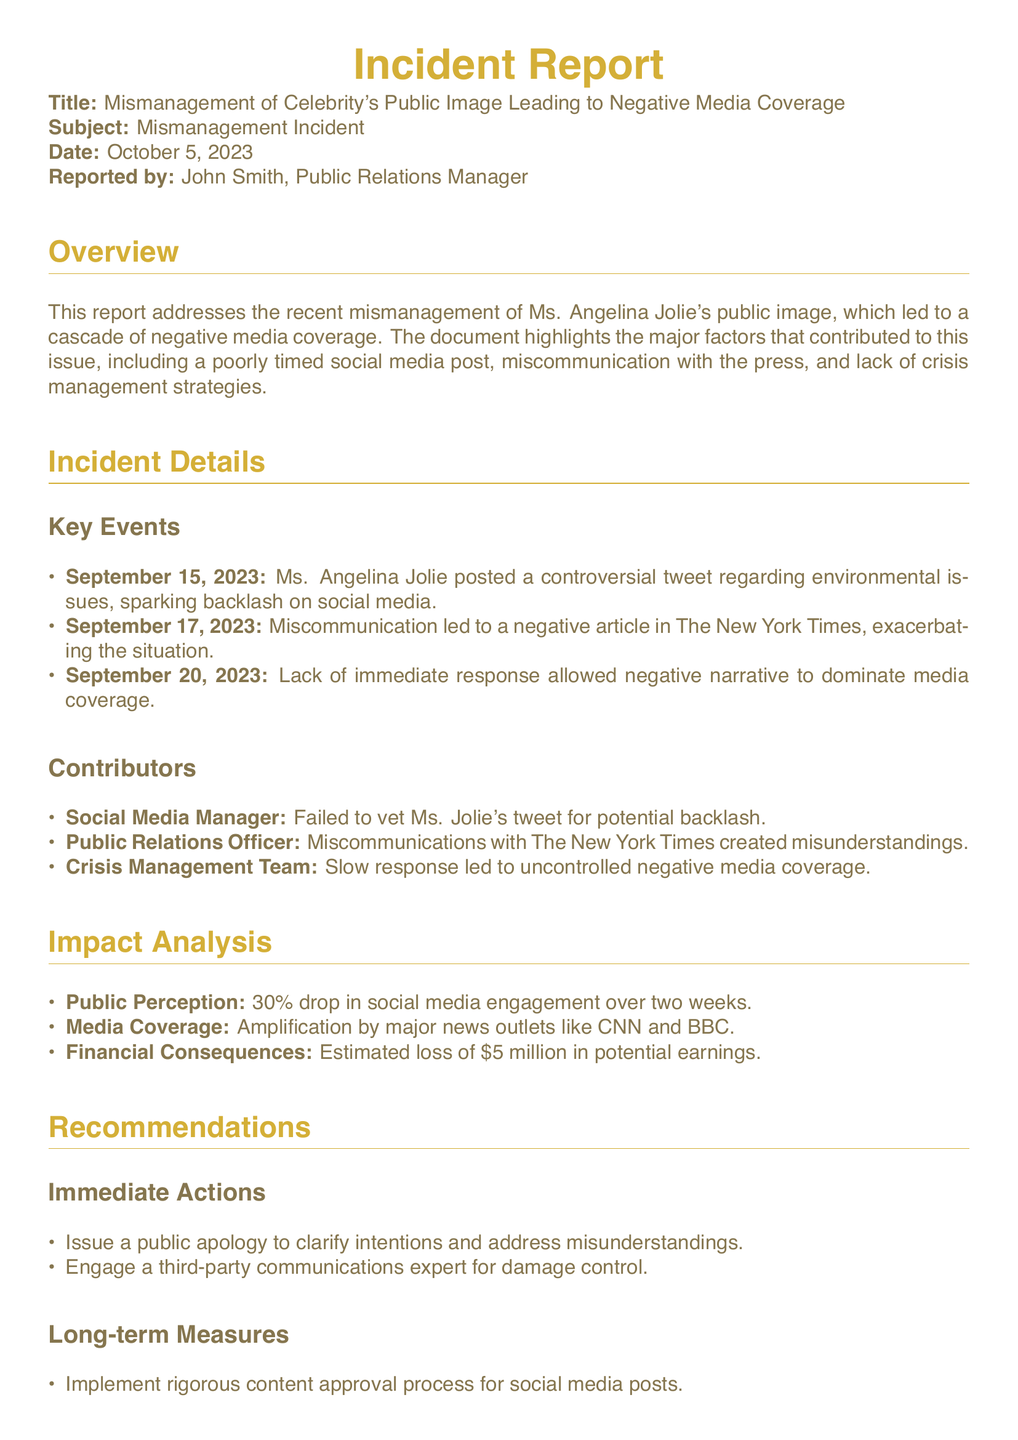What was the date of the reported incident? The report states the date of the incident as October 5, 2023.
Answer: October 5, 2023 Who reported the incident? The document indicates that John Smith, the Public Relations Manager, reported the incident.
Answer: John Smith What triggered the negative media coverage? The incident report indicates that a controversial tweet regarding environmental issues triggered the negative media coverage.
Answer: Controversial tweet How much was the estimated loss in potential earnings? The report specifies the estimated financial consequences as a loss of $5 million.
Answer: $5 million What percentage drop was observed in social media engagement? It is stated in the impact analysis that there was a 30% drop in social media engagement.
Answer: 30% What major news outlets amplified the media coverage? The incident report mentions CNN and BBC as major news outlets that amplified the media coverage.
Answer: CNN and BBC Which team member failed to vet the tweet? The social media manager is identified as the team member who failed to vet Ms. Jolie's tweet.
Answer: Social Media Manager What immediate action is recommended in the report? The report recommends issuing a public apology to clarify intentions.
Answer: Public apology What long-term measure is suggested for social media posts? The report suggests implementing a rigorous content approval process for social media posts.
Answer: Content approval process 